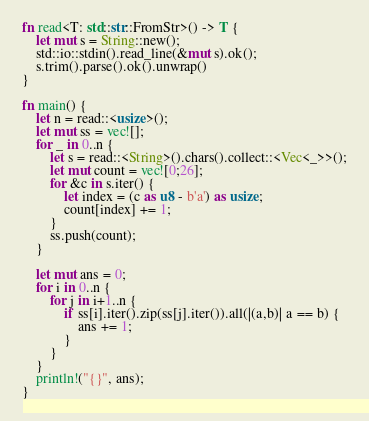Convert code to text. <code><loc_0><loc_0><loc_500><loc_500><_Rust_>fn read<T: std::str::FromStr>() -> T {
    let mut s = String::new();
    std::io::stdin().read_line(&mut s).ok();
    s.trim().parse().ok().unwrap()
}

fn main() {
    let n = read::<usize>();
    let mut ss = vec![];
    for _ in 0..n {
        let s = read::<String>().chars().collect::<Vec<_>>();
        let mut count = vec![0;26];
        for &c in s.iter() {
            let index = (c as u8 - b'a') as usize;
            count[index] += 1;
        }
        ss.push(count);
    }

    let mut ans = 0;
    for i in 0..n {
        for j in i+1..n {
            if ss[i].iter().zip(ss[j].iter()).all(|(a,b)| a == b) {
                ans += 1;
            }
        }
    }
    println!("{}", ans);
}</code> 